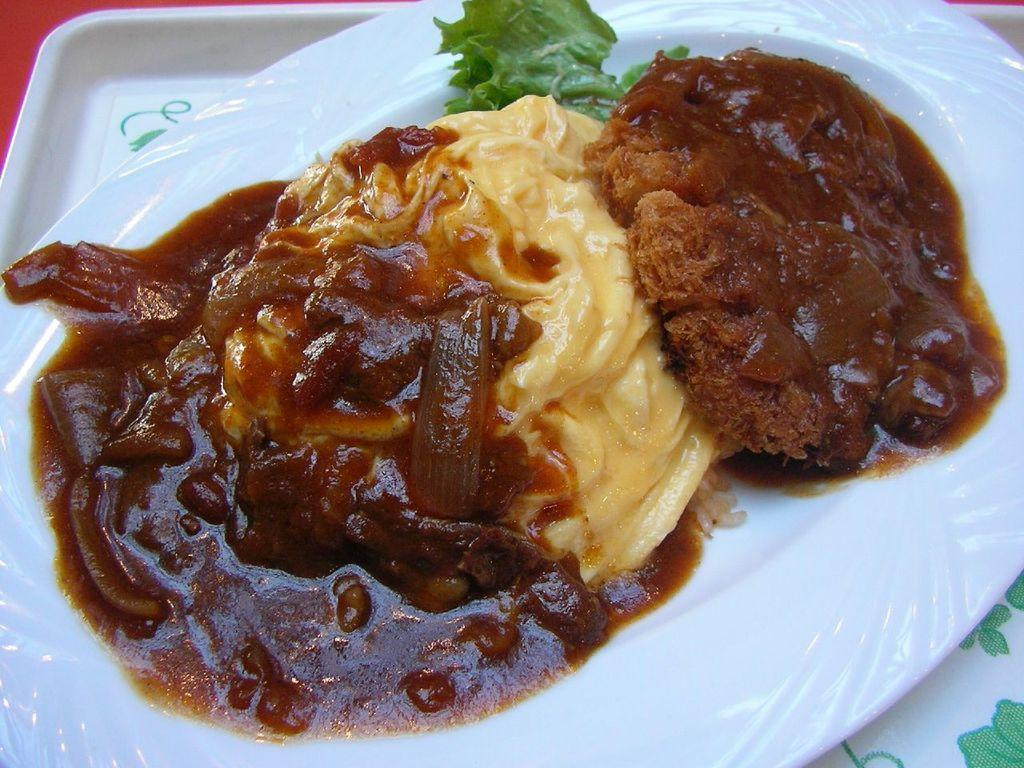What is present on the plate in the image? There are food items on a plate in the image. Can you tell me how many geese are depicted on the plate in the image? There are no geese present on the plate in the image; it contains food items. What type of glass is used to serve the food in the image? There is no glass present in the image; the food is served on a plate. 